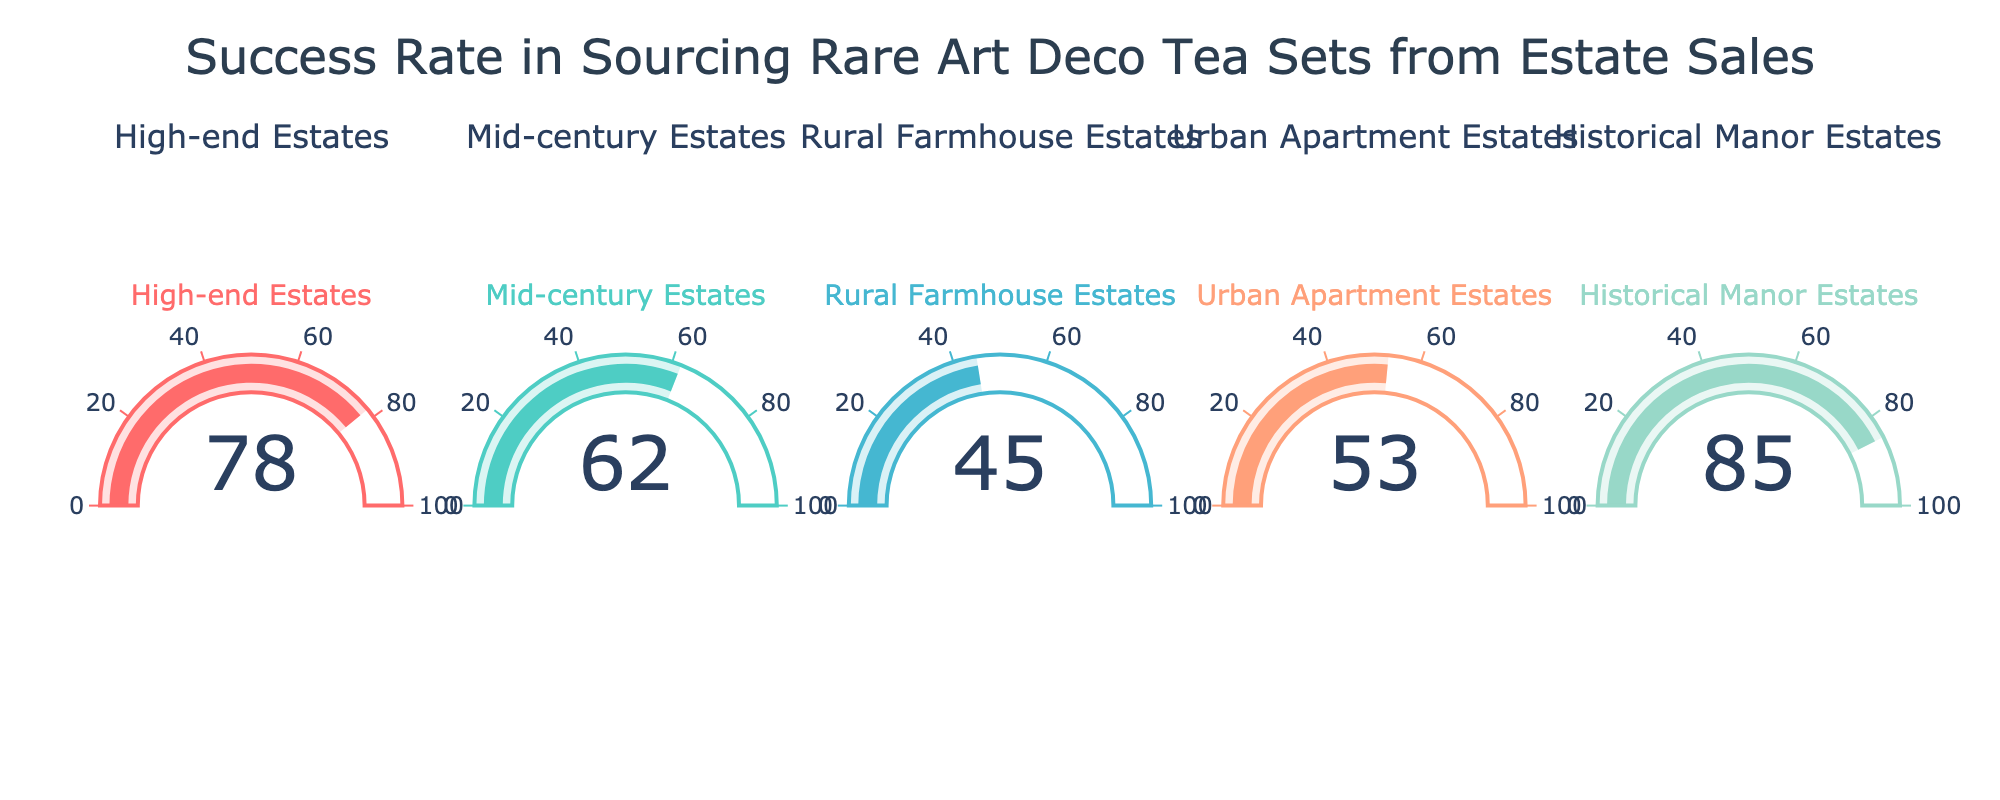What's the overall title of the figure? The title is displayed at the top of the figure. It states the main subject of the chart and provides context for the data being represented.
Answer: Success Rate in Sourcing Rare Art Deco Tea Sets from Estate Sales How many estate types are shown in the chart? By counting the number of subplots or gauges, we can see how many estate types are represented in the chart.
Answer: 5 Which estate type has the highest success rate? To find the highest success rate, look at the value displayed on each gauge and identify the largest number.
Answer: Historical Manor Estates Which estate type has the lowest success rate? To determine the lowest success rate, compare the values on each gauge and find the smallest number.
Answer: Rural Farmhouse Estates What's the success rate for Urban Apartment Estates? Locate the gauge for Urban Apartment Estates and read the number displayed.
Answer: 53 What's the difference in success rate between High-end Estates and Mid-century Estates? Subtract the success rate of Mid-century Estates (62) from that of High-end Estates (78).
Answer: 16 What's the average success rate of all estate types? Sum all the success rates (78 + 62 + 45 + 53 + 85) and divide by the number of estate types (5).
Answer: 64.6 What is the median success rate among the shown estate types? Arrange the success rates in numerical order (45, 53, 62, 78, 85) and find the middle value.
Answer: 62 Which two estate types have a combined success rate exceeding 130? By adding the success rates of each possible pair of estate types, find at least one pair where the sum is more than 130. The pairs are: High-end Estates (78) and Historical Manor Estates (85).
Answer: High-end Estates and Historical Manor Estates How does the success rate of Rural Farmhouse Estates compare to the average success rate? Compare the success rate of Rural Farmhouse Estates (45) against the previously calculated average (64.6). The success rate of Rural Farmhouse Estates is lower.
Answer: Lower 